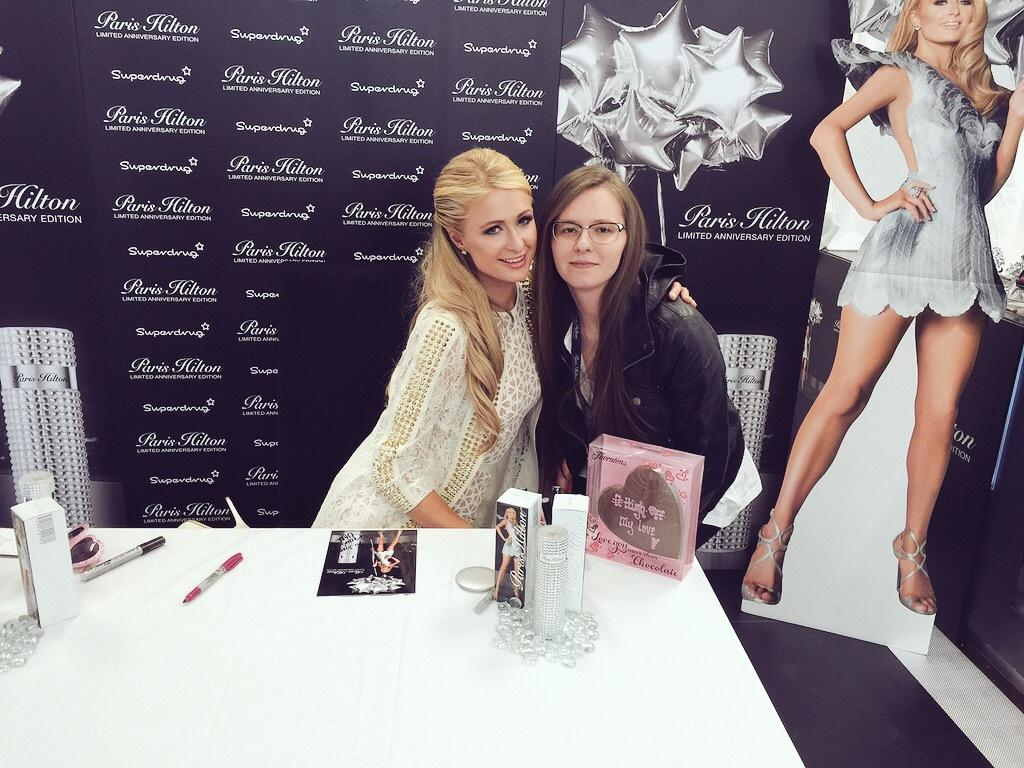How many people are in the image? There are two persons in the image. What is the background of the image? The persons are in front of a banner. What is located at the bottom of the image? There is a table at the bottom of the image. What items can be seen on the table? The table contains boxes and pens. What is present on the right side of the image? There is a cutout on the right side of the image. What type of verse can be seen on the banner in the image? There is no verse present on the banner in the image. What is the desire of the persons in the image? We cannot determine the desires of the persons in the image based on the provided facts. 